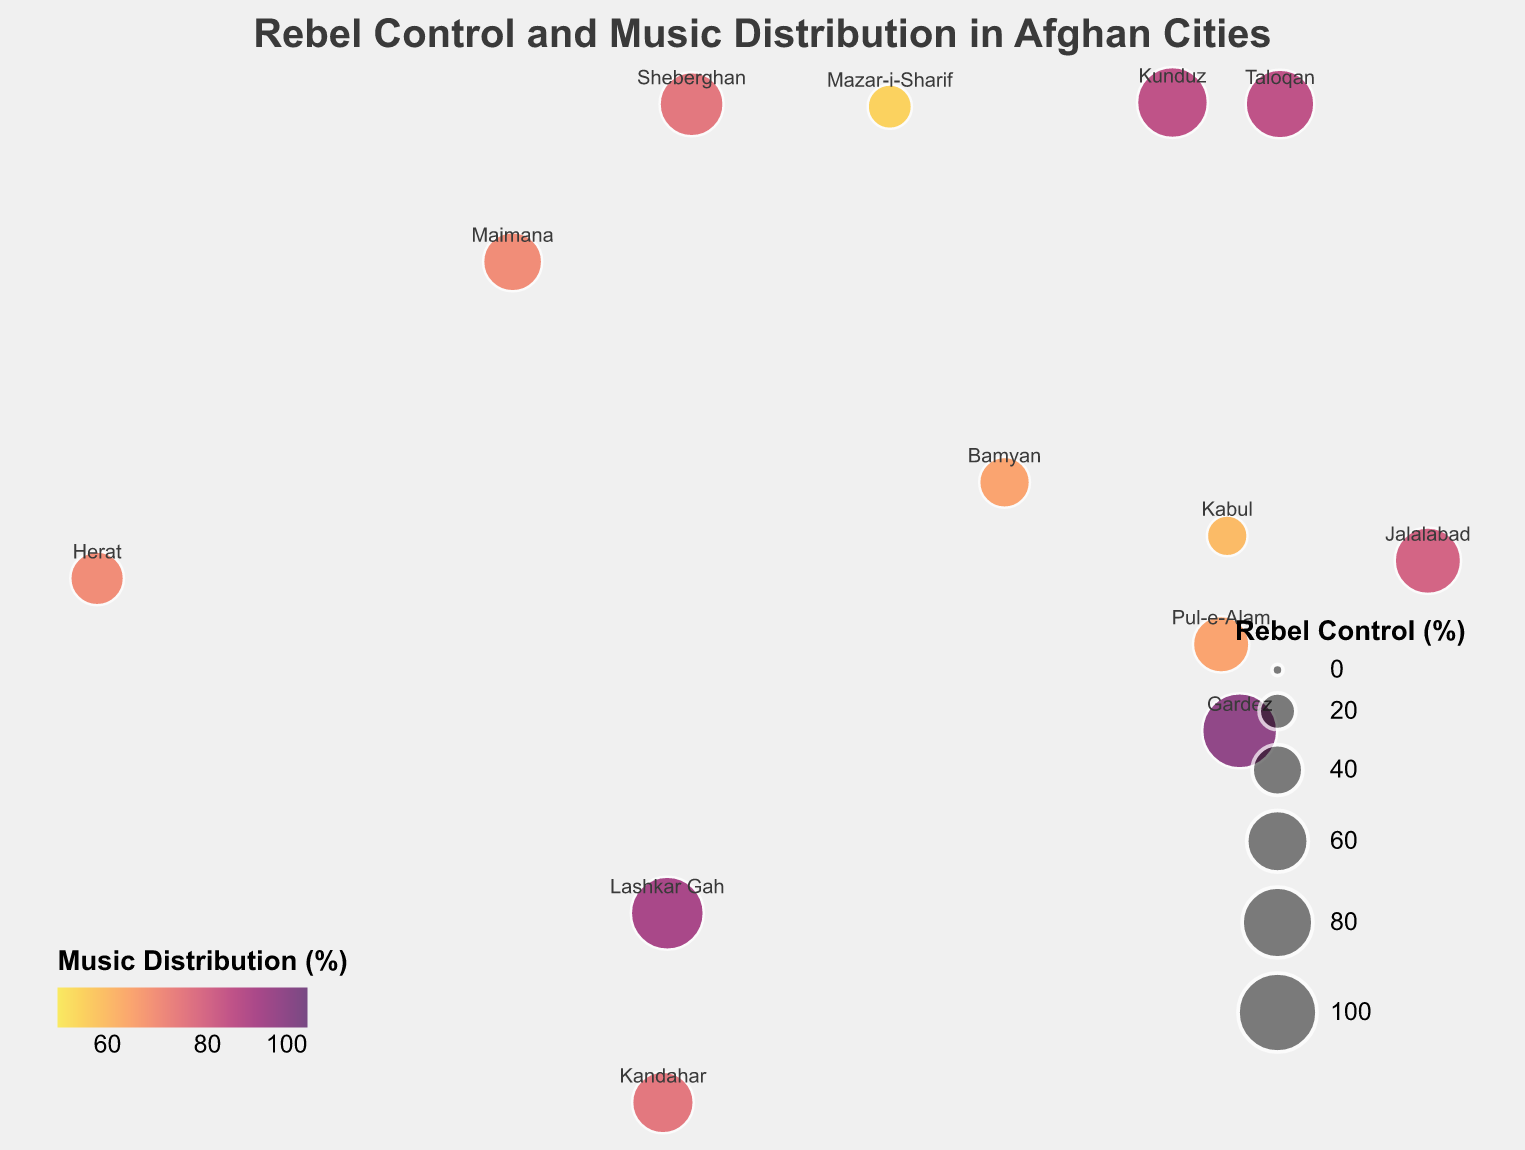What is the title of the map? The title of the map is usually displayed at the top of the figure in larger and bolder text. The given title shows "Rebel Control and Music Distribution in Afghan Cities".
Answer: Rebel Control and Music Distribution in Afghan Cities Which city has the highest Rebel Control percentage? By looking at the size of the circles, the largest circle corresponds to Gardez, which has a Rebel Control percentage of 90%.
Answer: Gardez Which city has the lowest Music Distribution percentage? By examining the color of the circles, the lightest colored circle belongs to Mazar-i-Sharif, which has a Music Distribution percentage of 55%.
Answer: Mazar-i-Sharif How does the Rebel Control in Jalalabad compare to the Rebel Control in Sheberghan? By comparing the sizes of the circles corresponding to both cities, Jalalabad has a Rebel Control percentage of 70%, while Sheberghan has 65%. Therefore, Jalalabad has a higher Rebel Control.
Answer: Jalalabad has higher Rebel Control What is the average Music Distribution percentage of Kabul and Herat? The Music Distribution percentages for Kabul and Herat are 60% and 70%, respectively. To find the average, sum these values (60 + 70) and divide by 2.
Answer: The average is 65% How many cities have a Rebel Control percentage above 60%? By identifying each city with a circle size indicating Rebel Control above 60%, the cities are Kunduz, Kandahar, Jalalabad, Gardez, Taloqan, Sheberghan, and Lashkar Gah. There are 7 cities in total.
Answer: 7 Which city has a higher combination of both Rebel Control and Music Distribution, Lashkar Gah or Kunduz? Lashkar Gah has Rebel Control and Music Distribution percentages of 85% and 90%, respectively. Kunduz has 80% Rebel Control and 85% Music Distribution. Summing these values for comparison: Lashkar Gah (85 + 90 = 175), Kunduz (80 + 85 = 165). Thus, Lashkar Gah has a higher combination of these metrics.
Answer: Lashkar Gah What is the correlation between Rebel Control and Music Distribution for the cities in the plot? By observing the figure, cities with higher Rebel Control percentages generally have higher Music Distribution percentages, suggesting a positive correlation.
Answer: Positive correlation How many cities are labeled on the map? Each city represented by a circle has a text label above or near it indicating its name. Counting these, we see there are 13 cities labeled on the map.
Answer: 13 Identify cities where Rebel Control is exactly 50%. By inspecting the sizes of the circles and their labels, the city with a Rebel Control percentage of exactly 50% is Pul-e-Alam.
Answer: Pul-e-Alam 